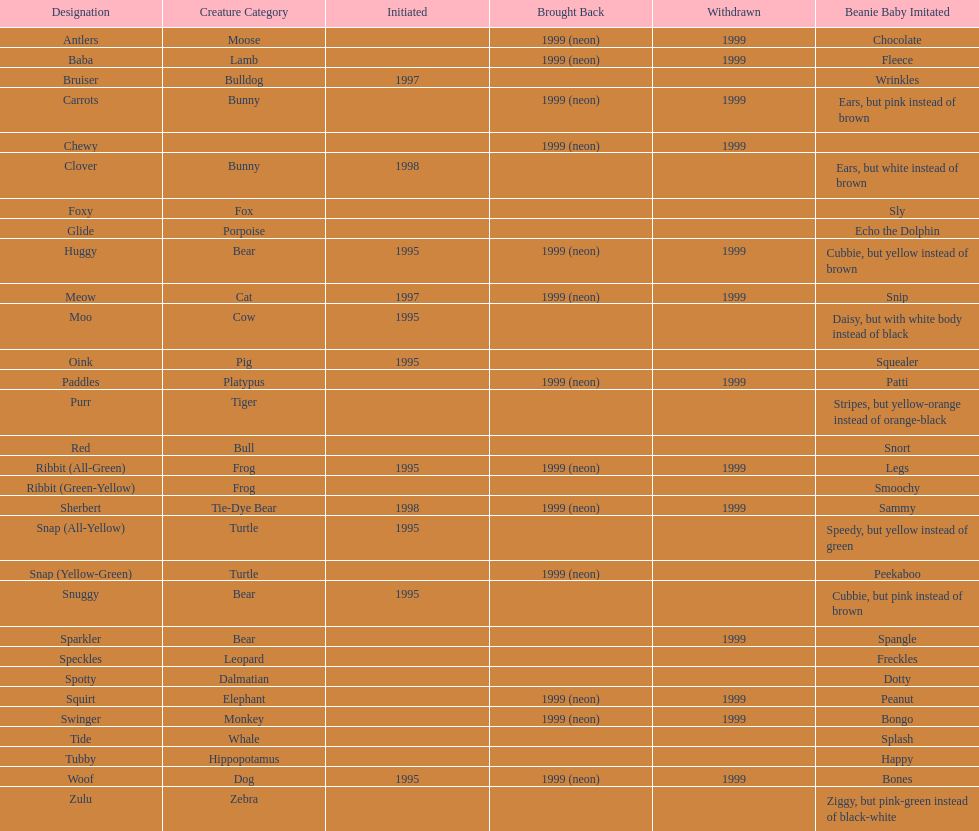How many monkey pillow pals were there? 1. 